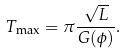<formula> <loc_0><loc_0><loc_500><loc_500>T _ { \max } = { \pi } \frac { { \sqrt { L } } } { G ( \phi ) } .</formula> 